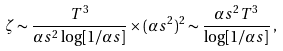<formula> <loc_0><loc_0><loc_500><loc_500>\zeta \sim \frac { T ^ { 3 } } { \alpha s ^ { 2 } \log [ 1 / \alpha s ] } \times ( \alpha s ^ { 2 } ) ^ { 2 } \sim \frac { \alpha s ^ { 2 } T ^ { 3 } } { \log [ 1 / \alpha s ] } \, ,</formula> 